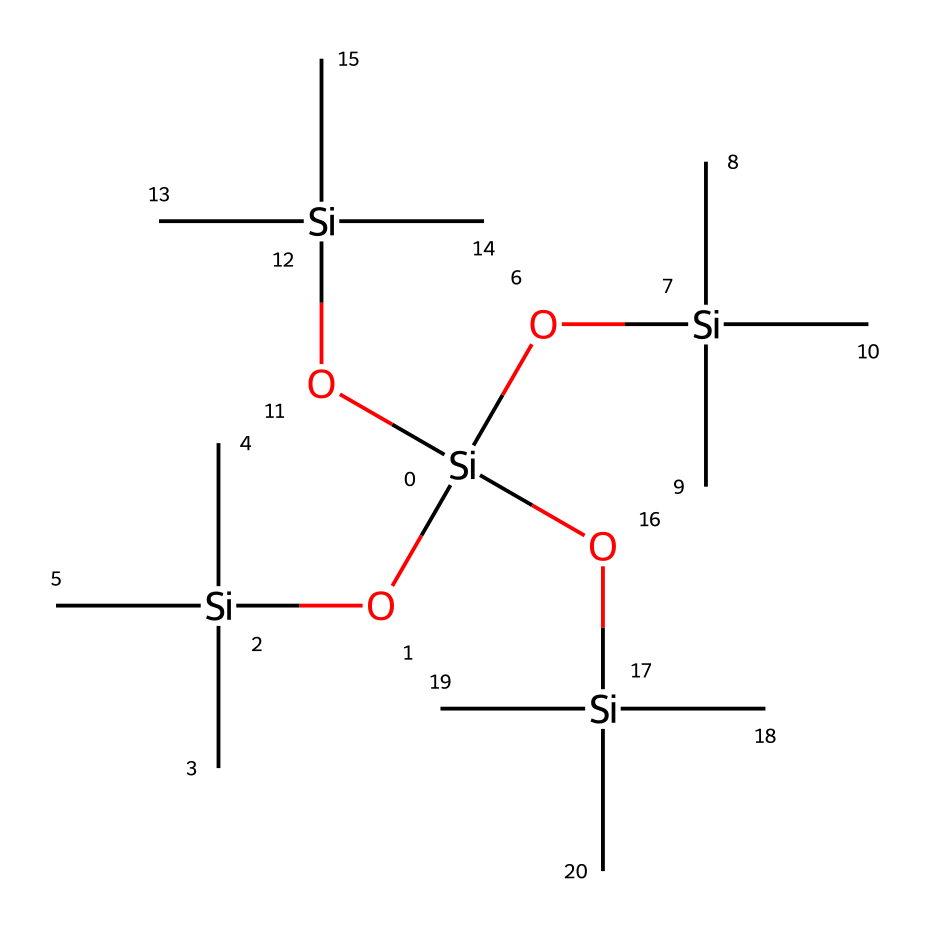What is the main functional group in this silicone-based lubricant? The chemical structure contains silicon (Si) atoms bonded with oxygen (O) and carbon (C) atoms. The presence of Si-O bonds indicates that this is a siloxane compound, which is a hallmark of silicone-based lubricants.
Answer: siloxane How many silicon atoms are present in the structure? By analyzing the SMILES representation, we can count the distinct Si atoms in the structure. There are five silicon atoms connected to various other atoms.
Answer: five What type of polymer structure does this chemical represent? The arrangement of silicon and oxygen atoms, along with the branching carbon chains, shows that this structure is a branched polysiloxane polymer. This type of structure is characteristic of silicone compounds.
Answer: branched polysiloxane What is the approximate degree of branching in this compound? By examining the branching of carbon chains attached to the silicon atoms, it can be observed that each silicon is connected to multiple carbon chains, reflecting a high degree of branching typical in silicone lubricants designed for smooth operation.
Answer: high Which property is primarily responsible for this compound's lubricating ability? The presence of siloxane links (Si-O-Si) contributes to low viscosity and high thermal stability, making this compound effective as a lubricant. This combination allows the lubricant to maintain performance under varied temperature and pressure.
Answer: low viscosity What is a common application of this organosilicon compound? This silicone-based compound is specifically formulated for use as a lubricant, often indicated as a component in motorcycle maintenance products to reduce friction and wear on mechanical parts.
Answer: lubricant What unique attribute do organosilicon compounds possess that contributes to their performance? Organosilicon compounds exhibit unique hydrophobic properties due to the silicon-oxygen backbone, leading to reduced wetting and enhanced lubrication in mechanical applications, particularly in environments where moisture is present.
Answer: hydrophobic properties 